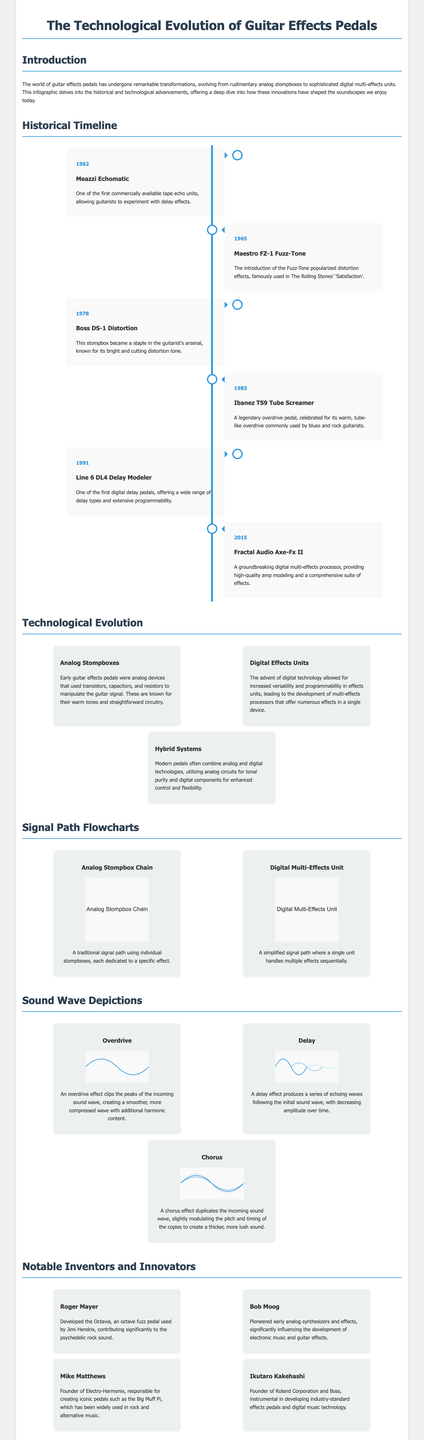what was the first commercially available tape echo unit? The document states that the Meazzi Echomatic was one of the first commercially available tape echo units.
Answer: Meazzi Echomatic what year was the Maestro FZ-1 Fuzz-Tone introduced? The historical timeline notes that the Maestro FZ-1 Fuzz-Tone was introduced in 1965.
Answer: 1965 which pedal is known for its warm, tube-like overdrive? According to the document, the Ibanez TS9 Tube Screamer is celebrated for its warm, tube-like overdrive.
Answer: Ibanez TS9 Tube Screamer who is the founder of Electro-Harmonix? The document mentions that Mike Matthews is the founder of Electro-Harmonix.
Answer: Mike Matthews what type of signal path does a digital multi-effects unit use? The document describes a digital multi-effects unit as having a simplified signal path where a single unit handles multiple effects.
Answer: Simplified signal path which inventor developed the Octavia pedal? According to the text, Roger Mayer developed the Octavia pedal used by Jimi Hendrix.
Answer: Roger Mayer how many major innovations are highlighted in the timeline? The timeline lists a total of 6 major innovations in guitar effects pedals dating from 1962 to 2015.
Answer: 6 what does an overdrive effect do to the sound wave? The document states that an overdrive effect clips the peaks of the incoming sound wave.
Answer: Clips the peaks in what section would you find sound wave depictions? The document includes a section specifically titled "Sound Wave Depictions."
Answer: Sound Wave Depictions 